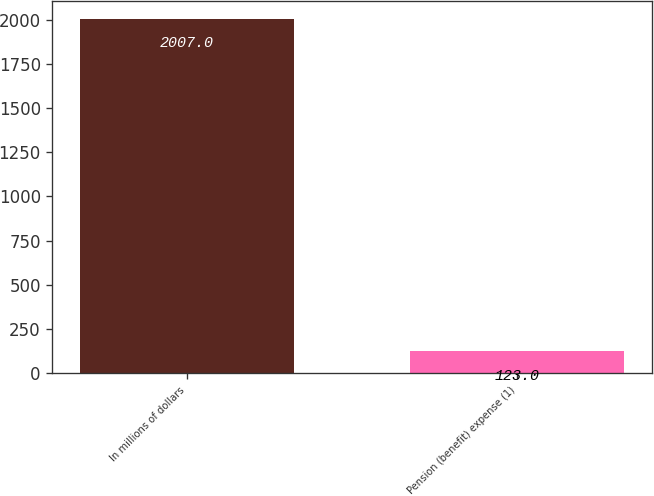Convert chart to OTSL. <chart><loc_0><loc_0><loc_500><loc_500><bar_chart><fcel>In millions of dollars<fcel>Pension (benefit) expense (1)<nl><fcel>2007<fcel>123<nl></chart> 